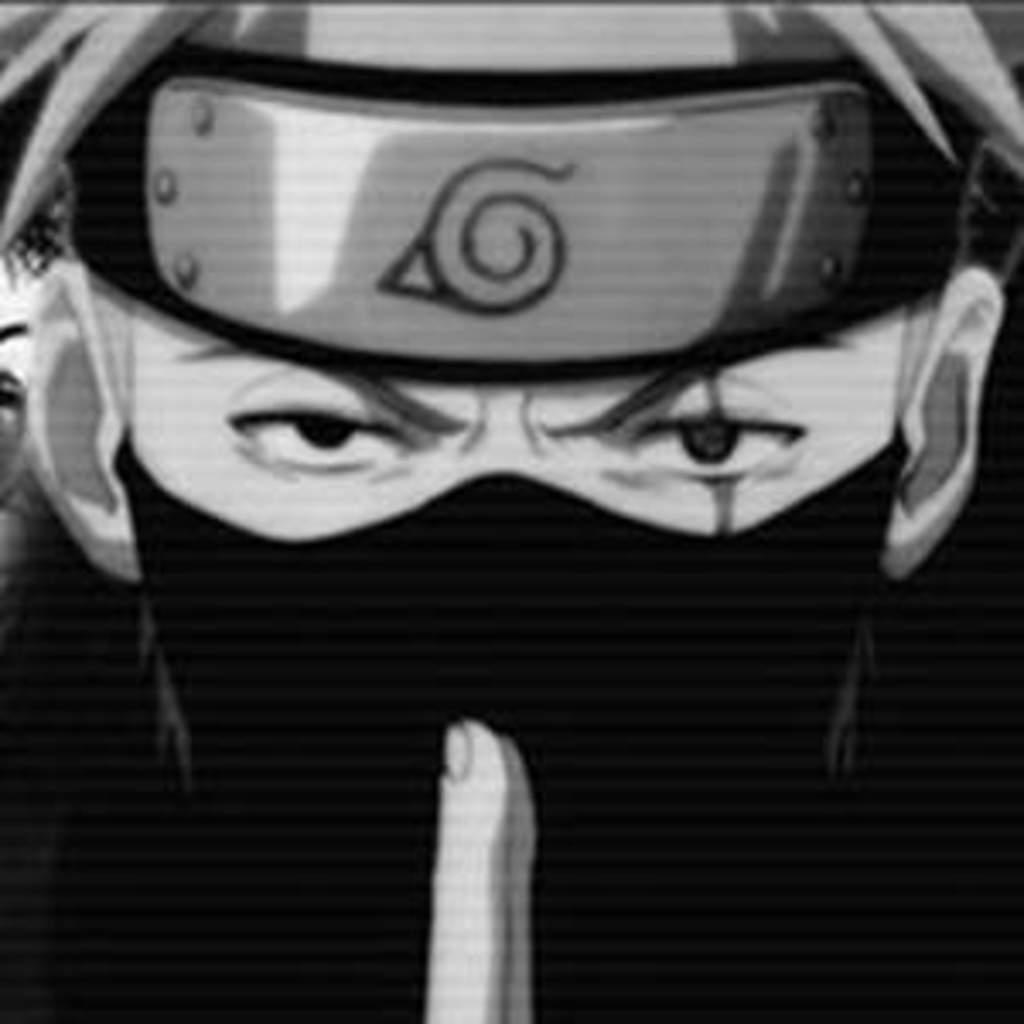What type of content is depicted in the image? There is a cartoon in the image. What type of apparel are the babies wearing in the image? There are no babies present in the image, as it only contains a cartoon. 